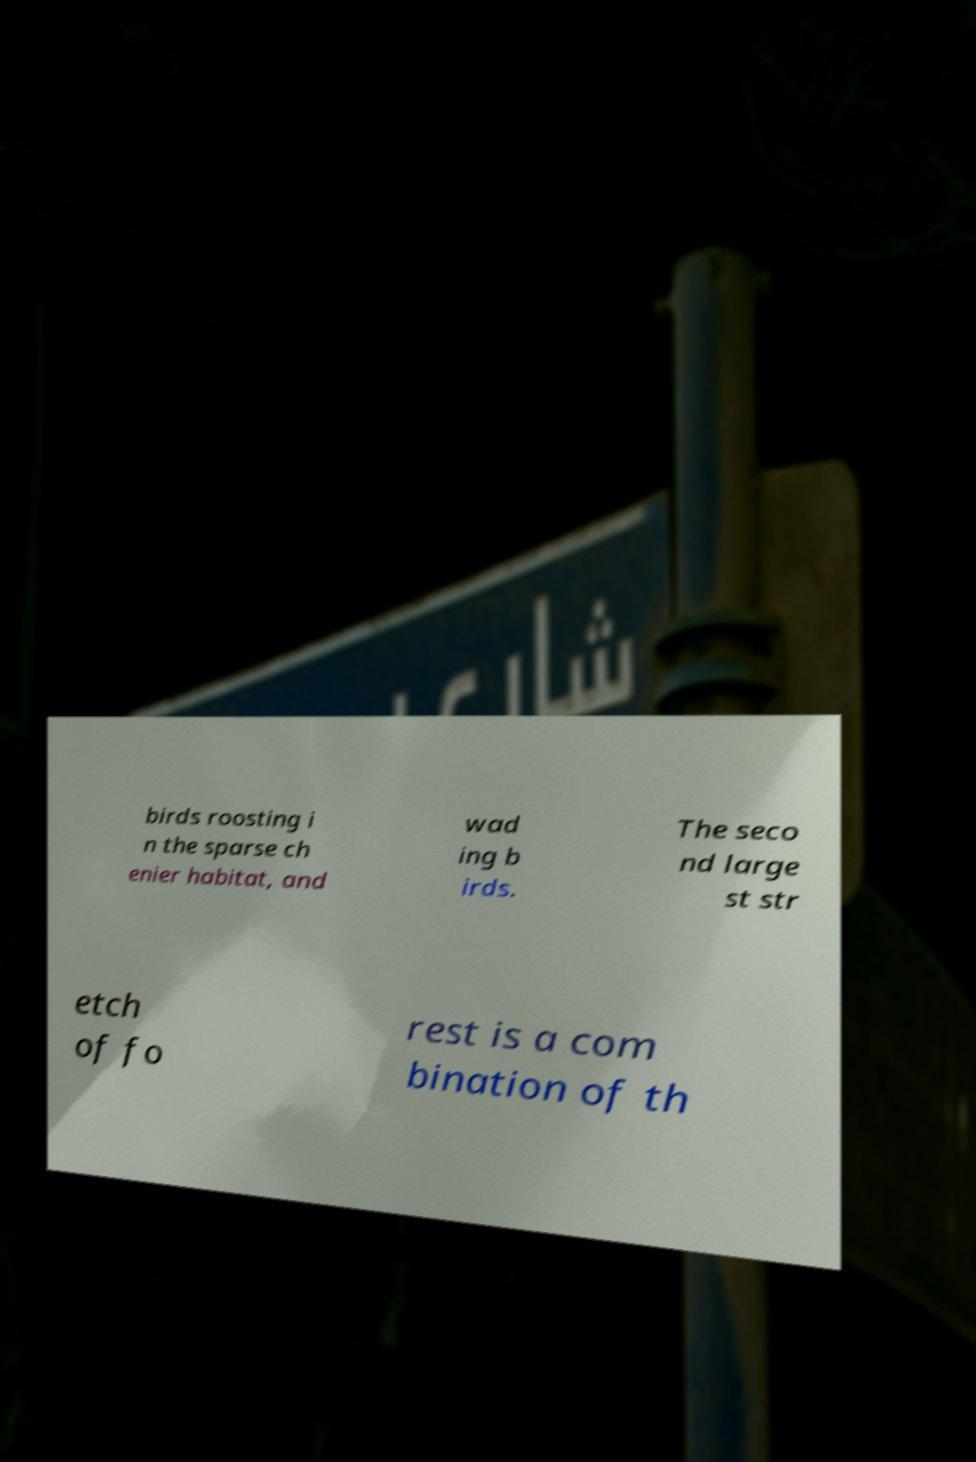Could you assist in decoding the text presented in this image and type it out clearly? birds roosting i n the sparse ch enier habitat, and wad ing b irds. The seco nd large st str etch of fo rest is a com bination of th 